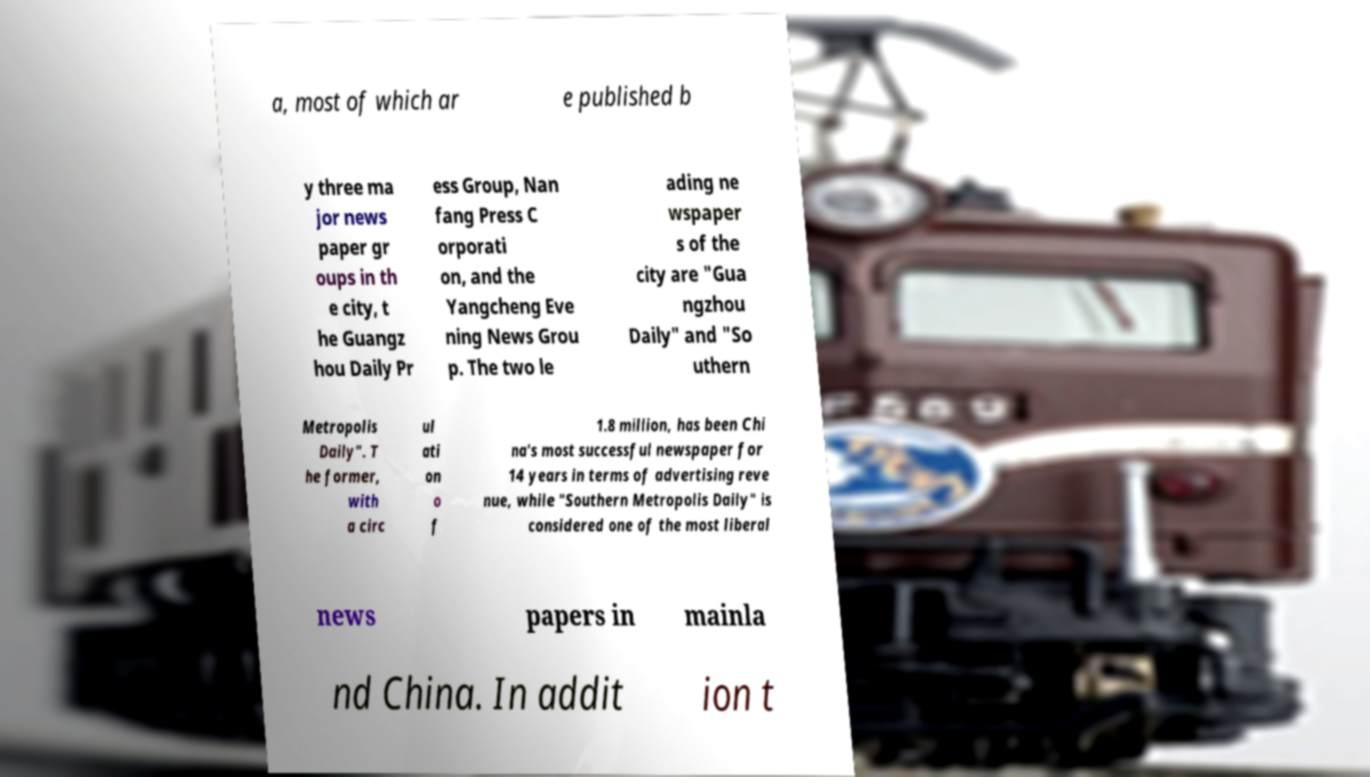Could you assist in decoding the text presented in this image and type it out clearly? a, most of which ar e published b y three ma jor news paper gr oups in th e city, t he Guangz hou Daily Pr ess Group, Nan fang Press C orporati on, and the Yangcheng Eve ning News Grou p. The two le ading ne wspaper s of the city are "Gua ngzhou Daily" and "So uthern Metropolis Daily". T he former, with a circ ul ati on o f 1.8 million, has been Chi na's most successful newspaper for 14 years in terms of advertising reve nue, while "Southern Metropolis Daily" is considered one of the most liberal news papers in mainla nd China. In addit ion t 